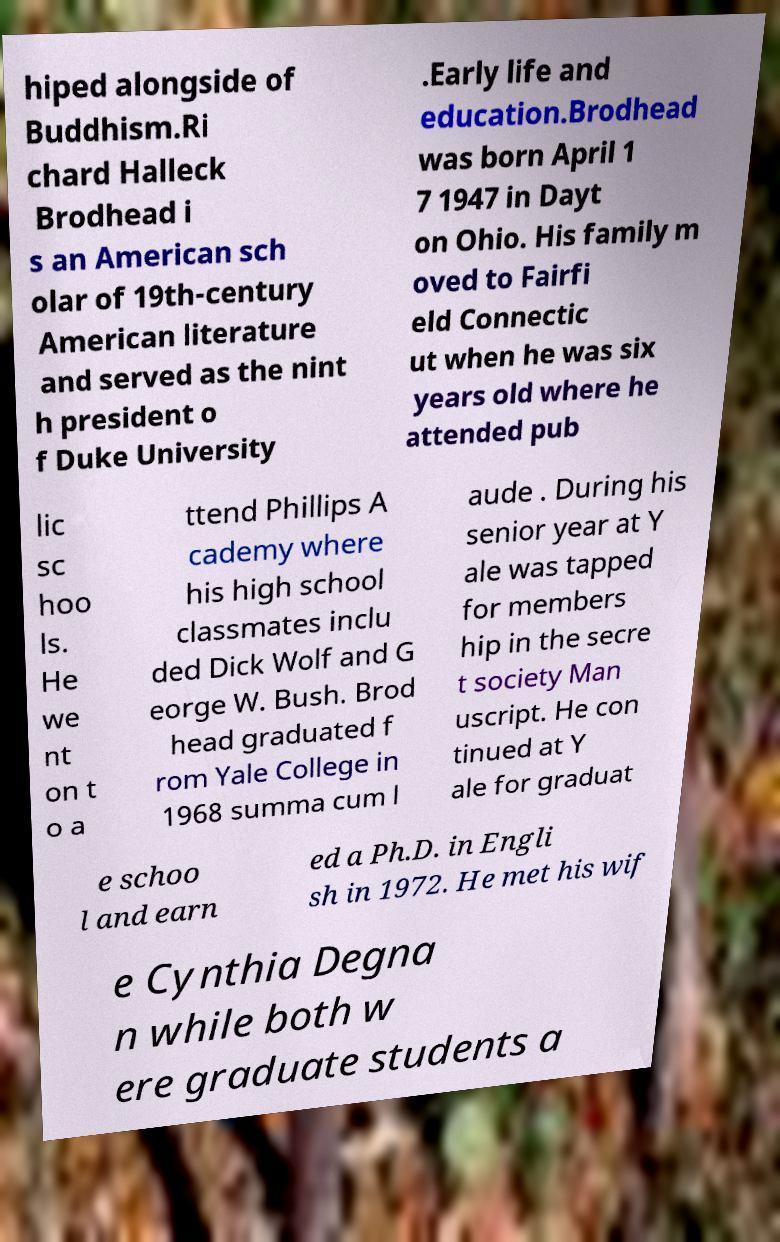Please identify and transcribe the text found in this image. hiped alongside of Buddhism.Ri chard Halleck Brodhead i s an American sch olar of 19th-century American literature and served as the nint h president o f Duke University .Early life and education.Brodhead was born April 1 7 1947 in Dayt on Ohio. His family m oved to Fairfi eld Connectic ut when he was six years old where he attended pub lic sc hoo ls. He we nt on t o a ttend Phillips A cademy where his high school classmates inclu ded Dick Wolf and G eorge W. Bush. Brod head graduated f rom Yale College in 1968 summa cum l aude . During his senior year at Y ale was tapped for members hip in the secre t society Man uscript. He con tinued at Y ale for graduat e schoo l and earn ed a Ph.D. in Engli sh in 1972. He met his wif e Cynthia Degna n while both w ere graduate students a 